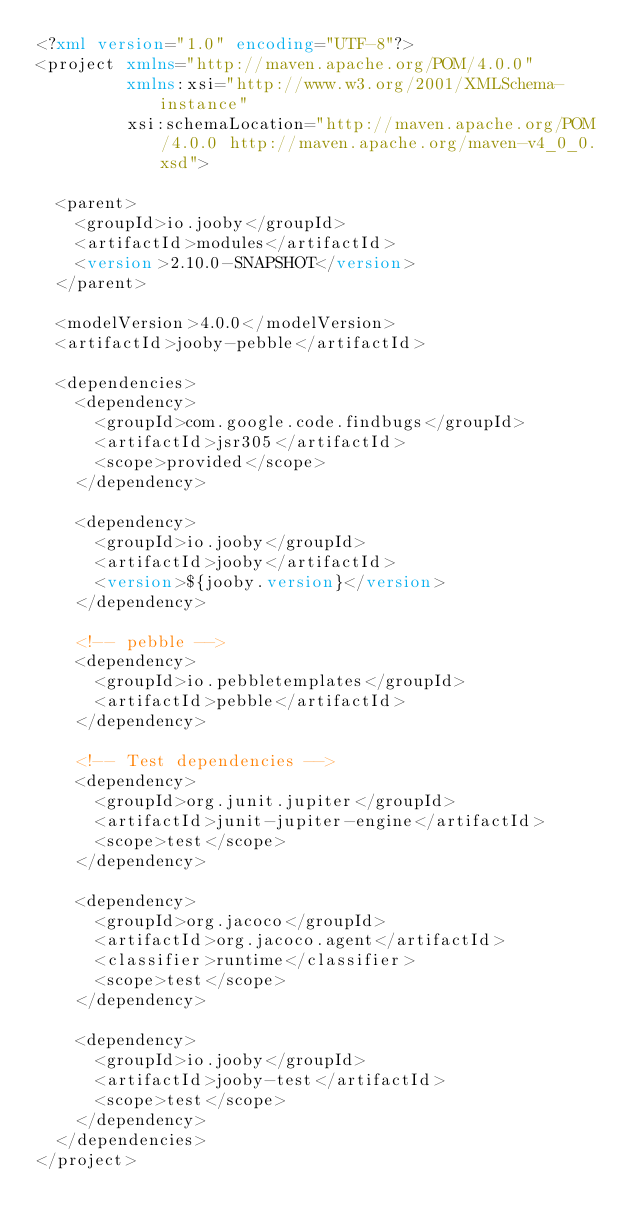Convert code to text. <code><loc_0><loc_0><loc_500><loc_500><_XML_><?xml version="1.0" encoding="UTF-8"?>
<project xmlns="http://maven.apache.org/POM/4.0.0"
         xmlns:xsi="http://www.w3.org/2001/XMLSchema-instance"
         xsi:schemaLocation="http://maven.apache.org/POM/4.0.0 http://maven.apache.org/maven-v4_0_0.xsd">

  <parent>
    <groupId>io.jooby</groupId>
    <artifactId>modules</artifactId>
    <version>2.10.0-SNAPSHOT</version>
  </parent>

  <modelVersion>4.0.0</modelVersion>
  <artifactId>jooby-pebble</artifactId>

  <dependencies>
    <dependency>
      <groupId>com.google.code.findbugs</groupId>
      <artifactId>jsr305</artifactId>
      <scope>provided</scope>
    </dependency>

    <dependency>
      <groupId>io.jooby</groupId>
      <artifactId>jooby</artifactId>
      <version>${jooby.version}</version>
    </dependency>

    <!-- pebble -->
    <dependency>
      <groupId>io.pebbletemplates</groupId>
      <artifactId>pebble</artifactId>
    </dependency>

    <!-- Test dependencies -->
    <dependency>
      <groupId>org.junit.jupiter</groupId>
      <artifactId>junit-jupiter-engine</artifactId>
      <scope>test</scope>
    </dependency>

    <dependency>
      <groupId>org.jacoco</groupId>
      <artifactId>org.jacoco.agent</artifactId>
      <classifier>runtime</classifier>
      <scope>test</scope>
    </dependency>

    <dependency>
      <groupId>io.jooby</groupId>
      <artifactId>jooby-test</artifactId>
      <scope>test</scope>
    </dependency>
  </dependencies>
</project>
</code> 